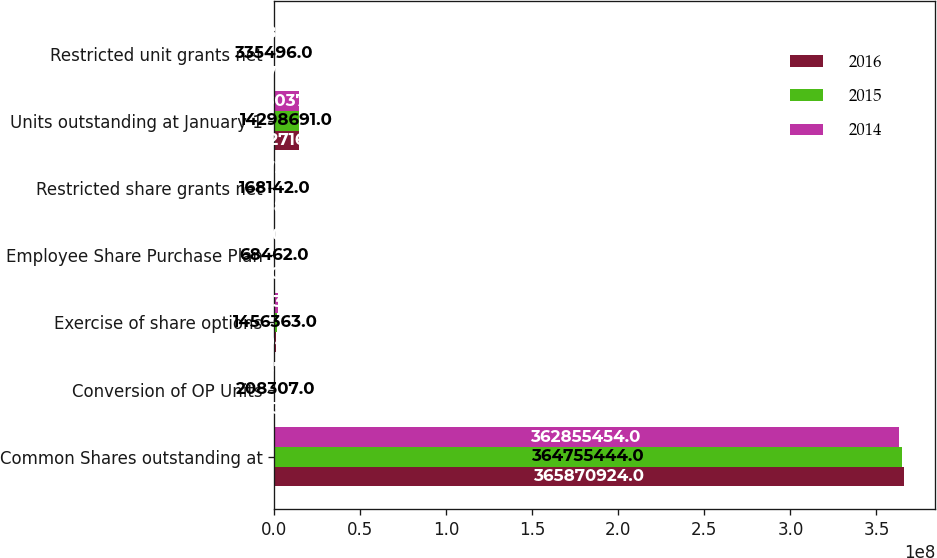Convert chart to OTSL. <chart><loc_0><loc_0><loc_500><loc_500><stacked_bar_chart><ecel><fcel>Common Shares outstanding at<fcel>Conversion of OP Units<fcel>Exercise of share options<fcel>Employee Share Purchase Plan<fcel>Restricted share grants net<fcel>Units outstanding at January 1<fcel>Restricted unit grants net<nl><fcel>2016<fcel>3.65871e+08<fcel>88838<fcel>815044<fcel>63909<fcel>147689<fcel>1.44272e+07<fcel>287749<nl><fcel>2015<fcel>3.64755e+08<fcel>208307<fcel>1.45636e+06<fcel>68462<fcel>168142<fcel>1.42987e+07<fcel>335496<nl><fcel>2014<fcel>3.62855e+08<fcel>94671<fcel>2.08638e+06<fcel>68807<fcel>169722<fcel>1.41804e+07<fcel>200840<nl></chart> 